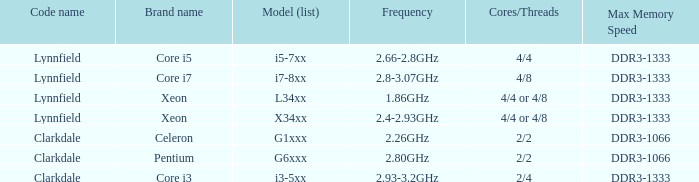How many cores are present in a ddr3-1333 with a frequency range of 2.66-2.8 ghz? 4/4. 